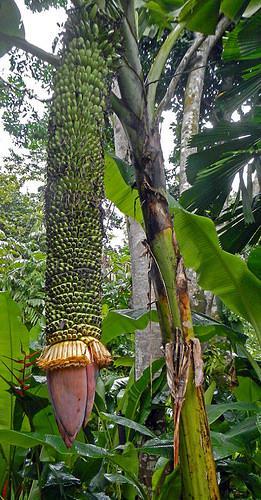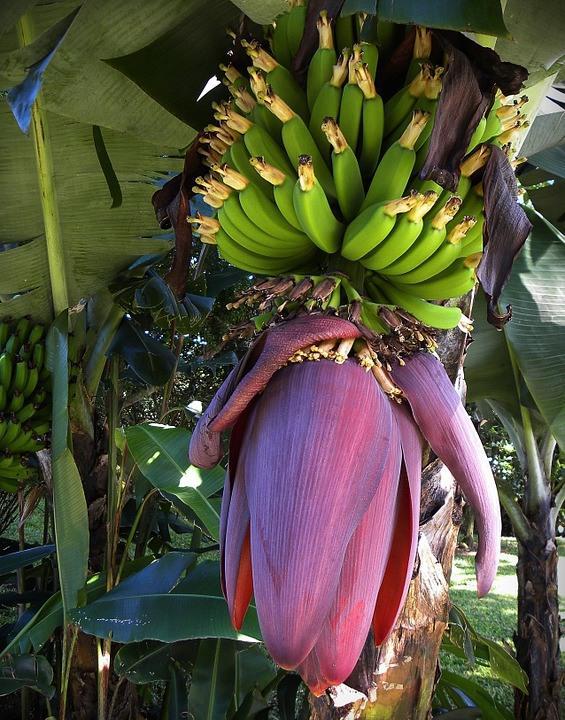The first image is the image on the left, the second image is the image on the right. Examine the images to the left and right. Is the description "The dark red undersides of multiple purple petals on a giant bulb that descends from a stalk are visible in each image." accurate? Answer yes or no. No. The first image is the image on the left, the second image is the image on the right. Given the left and right images, does the statement "In the image to the right, the banana flower is purple." hold true? Answer yes or no. Yes. 